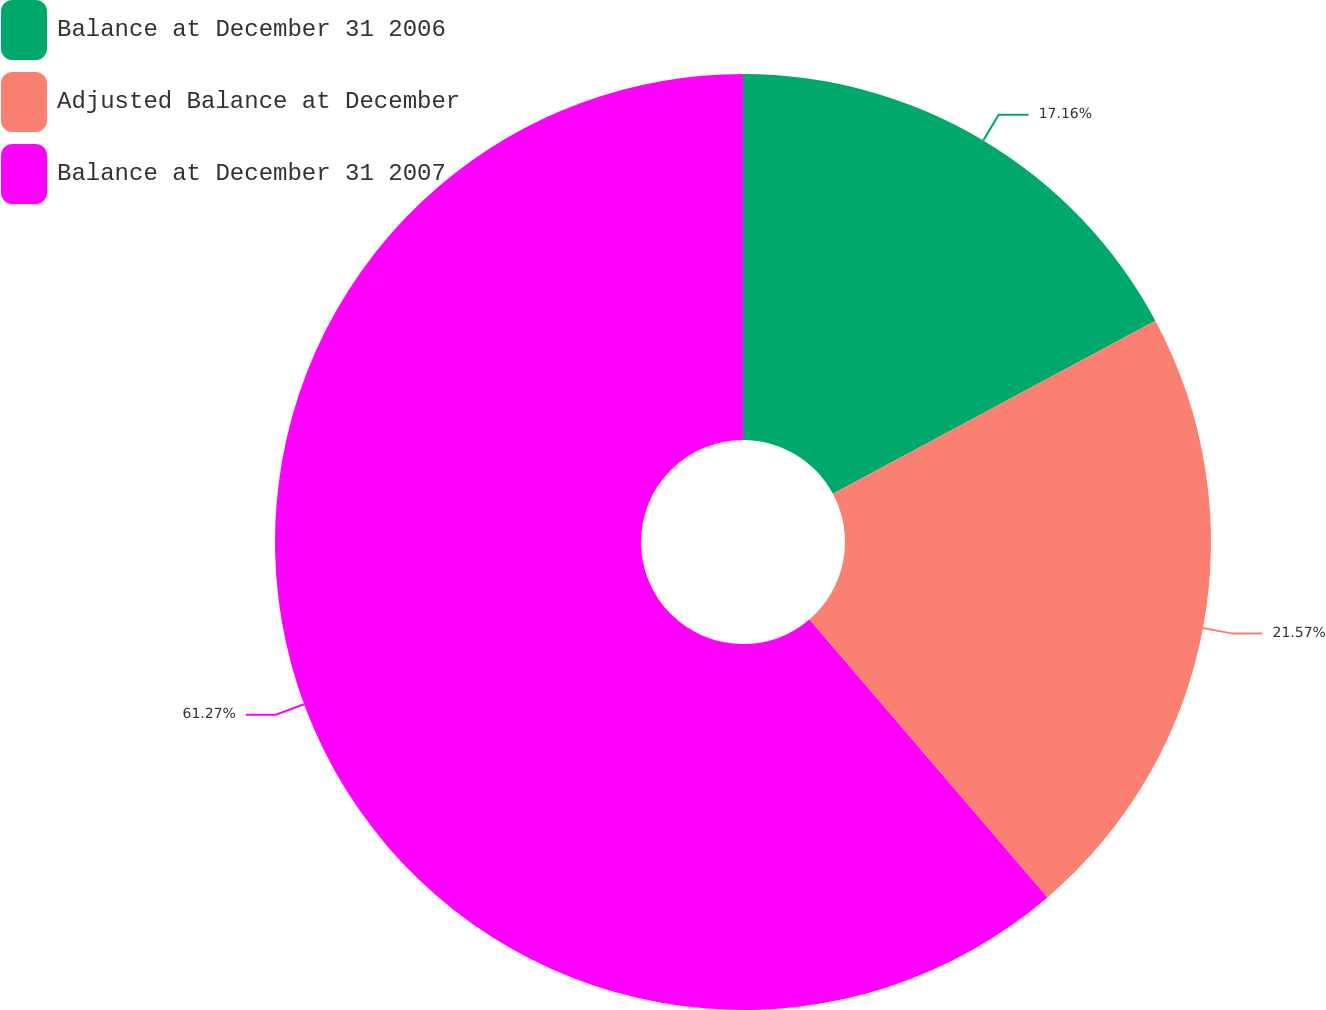Convert chart to OTSL. <chart><loc_0><loc_0><loc_500><loc_500><pie_chart><fcel>Balance at December 31 2006<fcel>Adjusted Balance at December<fcel>Balance at December 31 2007<nl><fcel>17.16%<fcel>21.57%<fcel>61.27%<nl></chart> 